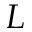<formula> <loc_0><loc_0><loc_500><loc_500>L</formula> 